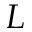<formula> <loc_0><loc_0><loc_500><loc_500>L</formula> 